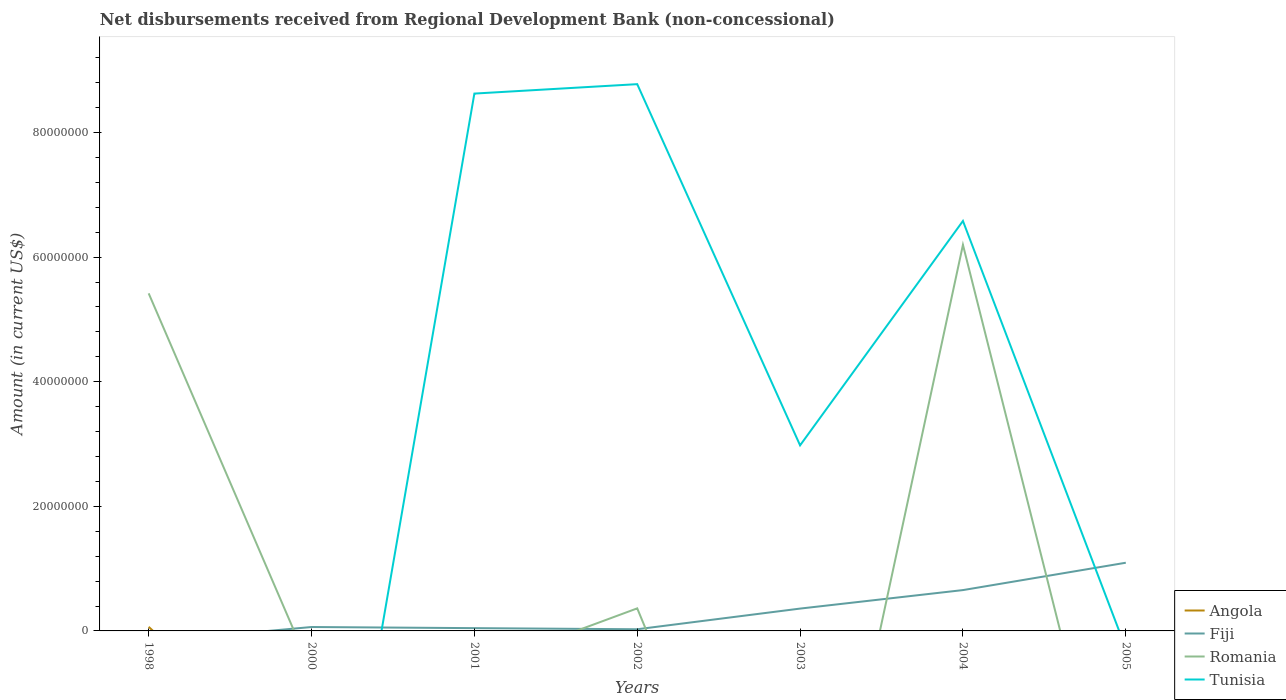Does the line corresponding to Romania intersect with the line corresponding to Tunisia?
Give a very brief answer. Yes. Is the number of lines equal to the number of legend labels?
Offer a very short reply. No. What is the total amount of disbursements received from Regional Development Bank in Fiji in the graph?
Keep it short and to the point. -7.36e+06. What is the difference between the highest and the second highest amount of disbursements received from Regional Development Bank in Tunisia?
Keep it short and to the point. 8.78e+07. How many years are there in the graph?
Give a very brief answer. 7. Are the values on the major ticks of Y-axis written in scientific E-notation?
Offer a terse response. No. How many legend labels are there?
Make the answer very short. 4. How are the legend labels stacked?
Your answer should be very brief. Vertical. What is the title of the graph?
Ensure brevity in your answer.  Net disbursements received from Regional Development Bank (non-concessional). What is the label or title of the X-axis?
Provide a succinct answer. Years. What is the label or title of the Y-axis?
Offer a terse response. Amount (in current US$). What is the Amount (in current US$) of Angola in 1998?
Ensure brevity in your answer.  6.58e+05. What is the Amount (in current US$) in Romania in 1998?
Give a very brief answer. 5.42e+07. What is the Amount (in current US$) of Angola in 2000?
Give a very brief answer. 0. What is the Amount (in current US$) in Fiji in 2000?
Ensure brevity in your answer.  6.27e+05. What is the Amount (in current US$) of Tunisia in 2000?
Your response must be concise. 0. What is the Amount (in current US$) in Angola in 2001?
Provide a succinct answer. 0. What is the Amount (in current US$) in Fiji in 2001?
Make the answer very short. 4.47e+05. What is the Amount (in current US$) in Romania in 2001?
Provide a short and direct response. 0. What is the Amount (in current US$) of Tunisia in 2001?
Provide a succinct answer. 8.62e+07. What is the Amount (in current US$) of Angola in 2002?
Your answer should be compact. 0. What is the Amount (in current US$) in Fiji in 2002?
Provide a short and direct response. 2.67e+05. What is the Amount (in current US$) in Romania in 2002?
Make the answer very short. 3.62e+06. What is the Amount (in current US$) of Tunisia in 2002?
Keep it short and to the point. 8.78e+07. What is the Amount (in current US$) in Fiji in 2003?
Provide a succinct answer. 3.58e+06. What is the Amount (in current US$) of Romania in 2003?
Keep it short and to the point. 0. What is the Amount (in current US$) of Tunisia in 2003?
Offer a terse response. 2.98e+07. What is the Amount (in current US$) in Angola in 2004?
Give a very brief answer. 0. What is the Amount (in current US$) in Fiji in 2004?
Make the answer very short. 6.55e+06. What is the Amount (in current US$) in Romania in 2004?
Your response must be concise. 6.20e+07. What is the Amount (in current US$) of Tunisia in 2004?
Keep it short and to the point. 6.58e+07. What is the Amount (in current US$) in Angola in 2005?
Your answer should be very brief. 0. What is the Amount (in current US$) in Fiji in 2005?
Offer a terse response. 1.09e+07. What is the Amount (in current US$) in Romania in 2005?
Offer a terse response. 0. What is the Amount (in current US$) of Tunisia in 2005?
Offer a very short reply. 0. Across all years, what is the maximum Amount (in current US$) in Angola?
Your response must be concise. 6.58e+05. Across all years, what is the maximum Amount (in current US$) in Fiji?
Your response must be concise. 1.09e+07. Across all years, what is the maximum Amount (in current US$) in Romania?
Provide a short and direct response. 6.20e+07. Across all years, what is the maximum Amount (in current US$) of Tunisia?
Your answer should be very brief. 8.78e+07. Across all years, what is the minimum Amount (in current US$) of Romania?
Your answer should be very brief. 0. Across all years, what is the minimum Amount (in current US$) in Tunisia?
Make the answer very short. 0. What is the total Amount (in current US$) in Angola in the graph?
Give a very brief answer. 6.58e+05. What is the total Amount (in current US$) of Fiji in the graph?
Provide a short and direct response. 2.24e+07. What is the total Amount (in current US$) in Romania in the graph?
Your answer should be very brief. 1.20e+08. What is the total Amount (in current US$) in Tunisia in the graph?
Give a very brief answer. 2.70e+08. What is the difference between the Amount (in current US$) in Romania in 1998 and that in 2002?
Your answer should be compact. 5.06e+07. What is the difference between the Amount (in current US$) of Romania in 1998 and that in 2004?
Ensure brevity in your answer.  -7.79e+06. What is the difference between the Amount (in current US$) in Fiji in 2000 and that in 2002?
Ensure brevity in your answer.  3.60e+05. What is the difference between the Amount (in current US$) of Fiji in 2000 and that in 2003?
Make the answer very short. -2.96e+06. What is the difference between the Amount (in current US$) in Fiji in 2000 and that in 2004?
Your answer should be very brief. -5.93e+06. What is the difference between the Amount (in current US$) of Fiji in 2000 and that in 2005?
Provide a short and direct response. -1.03e+07. What is the difference between the Amount (in current US$) in Tunisia in 2001 and that in 2002?
Your response must be concise. -1.51e+06. What is the difference between the Amount (in current US$) of Fiji in 2001 and that in 2003?
Provide a succinct answer. -3.14e+06. What is the difference between the Amount (in current US$) of Tunisia in 2001 and that in 2003?
Your answer should be very brief. 5.65e+07. What is the difference between the Amount (in current US$) of Fiji in 2001 and that in 2004?
Your answer should be compact. -6.11e+06. What is the difference between the Amount (in current US$) of Tunisia in 2001 and that in 2004?
Your response must be concise. 2.04e+07. What is the difference between the Amount (in current US$) in Fiji in 2001 and that in 2005?
Keep it short and to the point. -1.05e+07. What is the difference between the Amount (in current US$) of Fiji in 2002 and that in 2003?
Your answer should be very brief. -3.32e+06. What is the difference between the Amount (in current US$) in Tunisia in 2002 and that in 2003?
Your response must be concise. 5.80e+07. What is the difference between the Amount (in current US$) in Fiji in 2002 and that in 2004?
Provide a short and direct response. -6.29e+06. What is the difference between the Amount (in current US$) of Romania in 2002 and that in 2004?
Ensure brevity in your answer.  -5.84e+07. What is the difference between the Amount (in current US$) of Tunisia in 2002 and that in 2004?
Your answer should be compact. 2.20e+07. What is the difference between the Amount (in current US$) of Fiji in 2002 and that in 2005?
Offer a terse response. -1.07e+07. What is the difference between the Amount (in current US$) of Fiji in 2003 and that in 2004?
Offer a terse response. -2.97e+06. What is the difference between the Amount (in current US$) of Tunisia in 2003 and that in 2004?
Offer a very short reply. -3.60e+07. What is the difference between the Amount (in current US$) in Fiji in 2003 and that in 2005?
Offer a terse response. -7.36e+06. What is the difference between the Amount (in current US$) in Fiji in 2004 and that in 2005?
Give a very brief answer. -4.39e+06. What is the difference between the Amount (in current US$) in Angola in 1998 and the Amount (in current US$) in Fiji in 2000?
Provide a short and direct response. 3.10e+04. What is the difference between the Amount (in current US$) of Angola in 1998 and the Amount (in current US$) of Fiji in 2001?
Offer a very short reply. 2.11e+05. What is the difference between the Amount (in current US$) of Angola in 1998 and the Amount (in current US$) of Tunisia in 2001?
Provide a short and direct response. -8.56e+07. What is the difference between the Amount (in current US$) of Romania in 1998 and the Amount (in current US$) of Tunisia in 2001?
Your answer should be very brief. -3.21e+07. What is the difference between the Amount (in current US$) in Angola in 1998 and the Amount (in current US$) in Fiji in 2002?
Provide a short and direct response. 3.91e+05. What is the difference between the Amount (in current US$) of Angola in 1998 and the Amount (in current US$) of Romania in 2002?
Your answer should be very brief. -2.96e+06. What is the difference between the Amount (in current US$) in Angola in 1998 and the Amount (in current US$) in Tunisia in 2002?
Your response must be concise. -8.71e+07. What is the difference between the Amount (in current US$) in Romania in 1998 and the Amount (in current US$) in Tunisia in 2002?
Your response must be concise. -3.36e+07. What is the difference between the Amount (in current US$) of Angola in 1998 and the Amount (in current US$) of Fiji in 2003?
Your response must be concise. -2.93e+06. What is the difference between the Amount (in current US$) in Angola in 1998 and the Amount (in current US$) in Tunisia in 2003?
Keep it short and to the point. -2.91e+07. What is the difference between the Amount (in current US$) in Romania in 1998 and the Amount (in current US$) in Tunisia in 2003?
Your answer should be compact. 2.44e+07. What is the difference between the Amount (in current US$) of Angola in 1998 and the Amount (in current US$) of Fiji in 2004?
Your response must be concise. -5.90e+06. What is the difference between the Amount (in current US$) in Angola in 1998 and the Amount (in current US$) in Romania in 2004?
Your response must be concise. -6.13e+07. What is the difference between the Amount (in current US$) of Angola in 1998 and the Amount (in current US$) of Tunisia in 2004?
Provide a succinct answer. -6.51e+07. What is the difference between the Amount (in current US$) of Romania in 1998 and the Amount (in current US$) of Tunisia in 2004?
Offer a very short reply. -1.16e+07. What is the difference between the Amount (in current US$) in Angola in 1998 and the Amount (in current US$) in Fiji in 2005?
Ensure brevity in your answer.  -1.03e+07. What is the difference between the Amount (in current US$) of Fiji in 2000 and the Amount (in current US$) of Tunisia in 2001?
Give a very brief answer. -8.56e+07. What is the difference between the Amount (in current US$) of Fiji in 2000 and the Amount (in current US$) of Romania in 2002?
Provide a short and direct response. -2.99e+06. What is the difference between the Amount (in current US$) of Fiji in 2000 and the Amount (in current US$) of Tunisia in 2002?
Give a very brief answer. -8.71e+07. What is the difference between the Amount (in current US$) of Fiji in 2000 and the Amount (in current US$) of Tunisia in 2003?
Keep it short and to the point. -2.92e+07. What is the difference between the Amount (in current US$) in Fiji in 2000 and the Amount (in current US$) in Romania in 2004?
Keep it short and to the point. -6.13e+07. What is the difference between the Amount (in current US$) in Fiji in 2000 and the Amount (in current US$) in Tunisia in 2004?
Ensure brevity in your answer.  -6.52e+07. What is the difference between the Amount (in current US$) of Fiji in 2001 and the Amount (in current US$) of Romania in 2002?
Offer a very short reply. -3.17e+06. What is the difference between the Amount (in current US$) of Fiji in 2001 and the Amount (in current US$) of Tunisia in 2002?
Keep it short and to the point. -8.73e+07. What is the difference between the Amount (in current US$) in Fiji in 2001 and the Amount (in current US$) in Tunisia in 2003?
Provide a short and direct response. -2.93e+07. What is the difference between the Amount (in current US$) in Fiji in 2001 and the Amount (in current US$) in Romania in 2004?
Provide a short and direct response. -6.15e+07. What is the difference between the Amount (in current US$) of Fiji in 2001 and the Amount (in current US$) of Tunisia in 2004?
Keep it short and to the point. -6.54e+07. What is the difference between the Amount (in current US$) in Fiji in 2002 and the Amount (in current US$) in Tunisia in 2003?
Make the answer very short. -2.95e+07. What is the difference between the Amount (in current US$) in Romania in 2002 and the Amount (in current US$) in Tunisia in 2003?
Offer a very short reply. -2.62e+07. What is the difference between the Amount (in current US$) of Fiji in 2002 and the Amount (in current US$) of Romania in 2004?
Ensure brevity in your answer.  -6.17e+07. What is the difference between the Amount (in current US$) of Fiji in 2002 and the Amount (in current US$) of Tunisia in 2004?
Offer a very short reply. -6.55e+07. What is the difference between the Amount (in current US$) in Romania in 2002 and the Amount (in current US$) in Tunisia in 2004?
Your answer should be very brief. -6.22e+07. What is the difference between the Amount (in current US$) in Fiji in 2003 and the Amount (in current US$) in Romania in 2004?
Make the answer very short. -5.84e+07. What is the difference between the Amount (in current US$) of Fiji in 2003 and the Amount (in current US$) of Tunisia in 2004?
Give a very brief answer. -6.22e+07. What is the average Amount (in current US$) of Angola per year?
Offer a very short reply. 9.40e+04. What is the average Amount (in current US$) of Fiji per year?
Offer a very short reply. 3.20e+06. What is the average Amount (in current US$) in Romania per year?
Give a very brief answer. 1.71e+07. What is the average Amount (in current US$) in Tunisia per year?
Offer a terse response. 3.85e+07. In the year 1998, what is the difference between the Amount (in current US$) of Angola and Amount (in current US$) of Romania?
Offer a terse response. -5.35e+07. In the year 2001, what is the difference between the Amount (in current US$) of Fiji and Amount (in current US$) of Tunisia?
Give a very brief answer. -8.58e+07. In the year 2002, what is the difference between the Amount (in current US$) of Fiji and Amount (in current US$) of Romania?
Your response must be concise. -3.35e+06. In the year 2002, what is the difference between the Amount (in current US$) in Fiji and Amount (in current US$) in Tunisia?
Give a very brief answer. -8.75e+07. In the year 2002, what is the difference between the Amount (in current US$) of Romania and Amount (in current US$) of Tunisia?
Give a very brief answer. -8.41e+07. In the year 2003, what is the difference between the Amount (in current US$) of Fiji and Amount (in current US$) of Tunisia?
Keep it short and to the point. -2.62e+07. In the year 2004, what is the difference between the Amount (in current US$) in Fiji and Amount (in current US$) in Romania?
Offer a terse response. -5.54e+07. In the year 2004, what is the difference between the Amount (in current US$) of Fiji and Amount (in current US$) of Tunisia?
Provide a succinct answer. -5.92e+07. In the year 2004, what is the difference between the Amount (in current US$) in Romania and Amount (in current US$) in Tunisia?
Your response must be concise. -3.83e+06. What is the ratio of the Amount (in current US$) in Romania in 1998 to that in 2002?
Keep it short and to the point. 14.96. What is the ratio of the Amount (in current US$) in Romania in 1998 to that in 2004?
Your answer should be compact. 0.87. What is the ratio of the Amount (in current US$) in Fiji in 2000 to that in 2001?
Provide a short and direct response. 1.4. What is the ratio of the Amount (in current US$) of Fiji in 2000 to that in 2002?
Provide a short and direct response. 2.35. What is the ratio of the Amount (in current US$) of Fiji in 2000 to that in 2003?
Ensure brevity in your answer.  0.17. What is the ratio of the Amount (in current US$) in Fiji in 2000 to that in 2004?
Provide a short and direct response. 0.1. What is the ratio of the Amount (in current US$) in Fiji in 2000 to that in 2005?
Offer a very short reply. 0.06. What is the ratio of the Amount (in current US$) of Fiji in 2001 to that in 2002?
Your answer should be very brief. 1.67. What is the ratio of the Amount (in current US$) in Tunisia in 2001 to that in 2002?
Make the answer very short. 0.98. What is the ratio of the Amount (in current US$) in Fiji in 2001 to that in 2003?
Make the answer very short. 0.12. What is the ratio of the Amount (in current US$) in Tunisia in 2001 to that in 2003?
Your response must be concise. 2.9. What is the ratio of the Amount (in current US$) in Fiji in 2001 to that in 2004?
Keep it short and to the point. 0.07. What is the ratio of the Amount (in current US$) in Tunisia in 2001 to that in 2004?
Your response must be concise. 1.31. What is the ratio of the Amount (in current US$) of Fiji in 2001 to that in 2005?
Offer a very short reply. 0.04. What is the ratio of the Amount (in current US$) in Fiji in 2002 to that in 2003?
Offer a very short reply. 0.07. What is the ratio of the Amount (in current US$) in Tunisia in 2002 to that in 2003?
Keep it short and to the point. 2.95. What is the ratio of the Amount (in current US$) of Fiji in 2002 to that in 2004?
Offer a terse response. 0.04. What is the ratio of the Amount (in current US$) in Romania in 2002 to that in 2004?
Your response must be concise. 0.06. What is the ratio of the Amount (in current US$) of Tunisia in 2002 to that in 2004?
Provide a short and direct response. 1.33. What is the ratio of the Amount (in current US$) of Fiji in 2002 to that in 2005?
Provide a succinct answer. 0.02. What is the ratio of the Amount (in current US$) of Fiji in 2003 to that in 2004?
Your answer should be compact. 0.55. What is the ratio of the Amount (in current US$) of Tunisia in 2003 to that in 2004?
Keep it short and to the point. 0.45. What is the ratio of the Amount (in current US$) of Fiji in 2003 to that in 2005?
Your answer should be very brief. 0.33. What is the ratio of the Amount (in current US$) in Fiji in 2004 to that in 2005?
Your answer should be compact. 0.6. What is the difference between the highest and the second highest Amount (in current US$) of Fiji?
Offer a very short reply. 4.39e+06. What is the difference between the highest and the second highest Amount (in current US$) in Romania?
Provide a succinct answer. 7.79e+06. What is the difference between the highest and the second highest Amount (in current US$) of Tunisia?
Provide a short and direct response. 1.51e+06. What is the difference between the highest and the lowest Amount (in current US$) of Angola?
Your answer should be compact. 6.58e+05. What is the difference between the highest and the lowest Amount (in current US$) of Fiji?
Provide a succinct answer. 1.09e+07. What is the difference between the highest and the lowest Amount (in current US$) in Romania?
Offer a terse response. 6.20e+07. What is the difference between the highest and the lowest Amount (in current US$) in Tunisia?
Provide a short and direct response. 8.78e+07. 